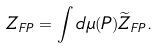Convert formula to latex. <formula><loc_0><loc_0><loc_500><loc_500>Z _ { F P } = \int d \mu ( P ) \widetilde { Z } _ { F P } .</formula> 